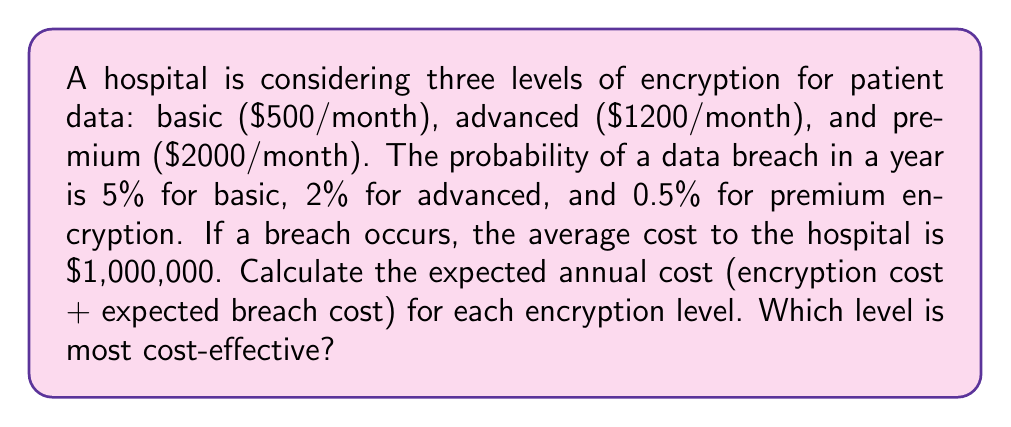Show me your answer to this math problem. Let's calculate the expected annual cost for each encryption level:

1. Basic Encryption:
   - Annual encryption cost: $500 × 12 = $6,000
   - Probability of breach: 5% = 0.05
   - Expected breach cost: $1,000,000 × 0.05 = $50,000
   - Total expected annual cost: $6,000 + $50,000 = $56,000

2. Advanced Encryption:
   - Annual encryption cost: $1,200 × 12 = $14,400
   - Probability of breach: 2% = 0.02
   - Expected breach cost: $1,000,000 × 0.02 = $20,000
   - Total expected annual cost: $14,400 + $20,000 = $34,400

3. Premium Encryption:
   - Annual encryption cost: $2,000 × 12 = $24,000
   - Probability of breach: 0.5% = 0.005
   - Expected breach cost: $1,000,000 × 0.005 = $5,000
   - Total expected annual cost: $24,000 + $5,000 = $29,000

The most cost-effective option is the one with the lowest total expected annual cost, which is the Premium Encryption at $29,000 per year.
Answer: Premium Encryption ($29,000/year) 